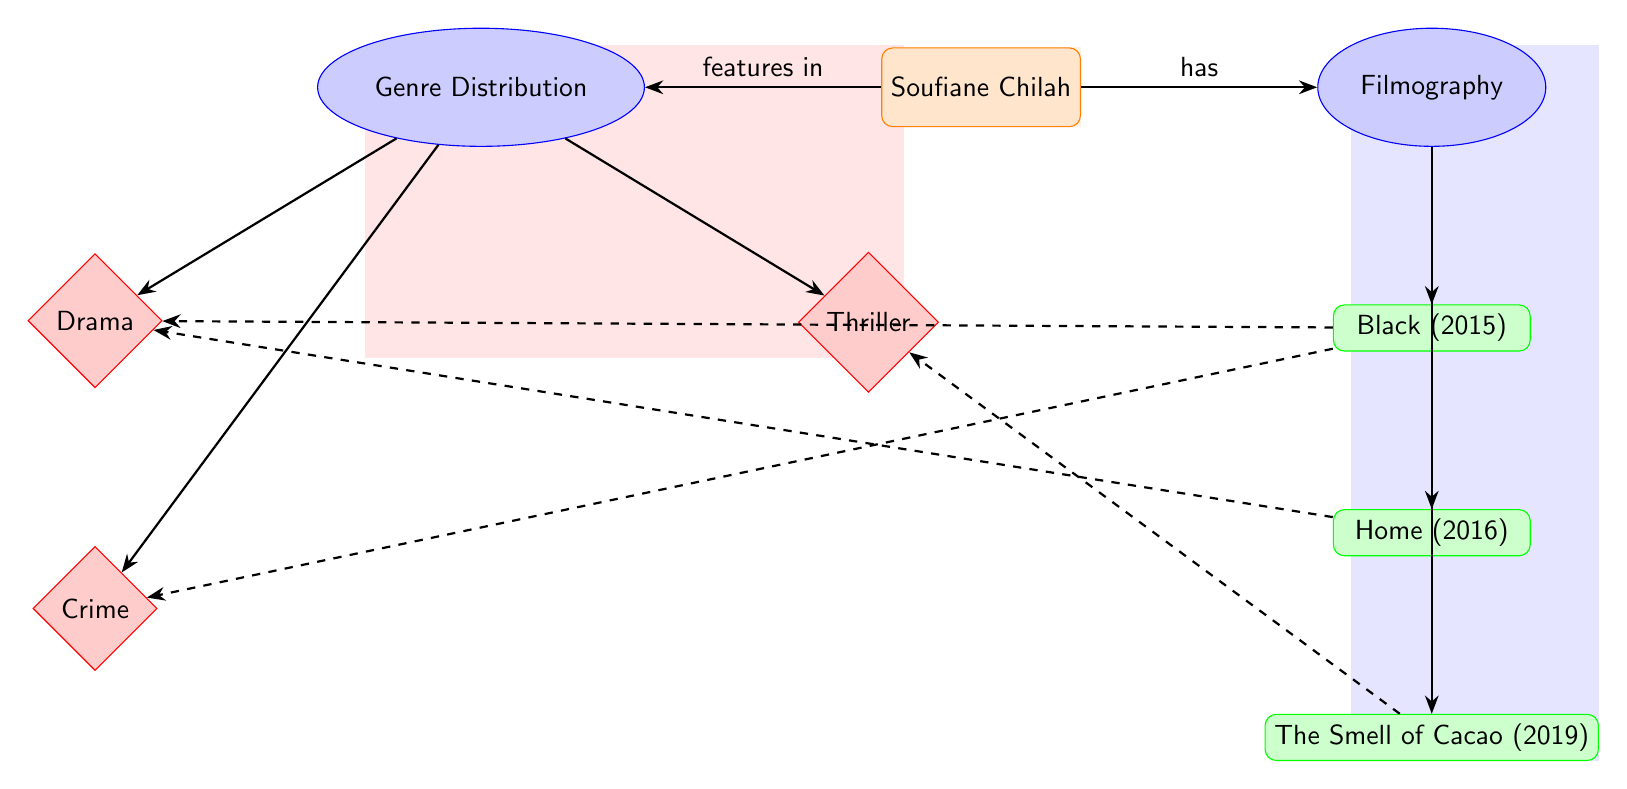What films are listed in Soufiane Chilah's filmography? The diagram shows three films listed under Soufiane Chilah's filmography: "Black (2015)", "Home (2016)", and "The Smell of Cacao (2019)". These are represented as nodes connected to the filmography node in the diagram.
Answer: Black (2015), Home (2016), The Smell of Cacao (2019) How many genres are featured in the diagram? There are three genres represented in the diagram: Drama, Crime, and Thriller. Each genre is depicted as a separate node connected to the genre distribution node. Counting these nodes gives a total of three genres.
Answer: 3 Which film corresponds to the Crime genre? Looking at the edges connecting the film nodes to the genre node, "Black (2015)" has dashed edges leading to both the Crime and Drama genres. This indicates that "Black" can be categorized under Crime.
Answer: Black (2015) Which film is classified as a Thriller? The film node "The Smell of Cacao (2019)" is connected by a dashed edge to the Thriller genre node, categorizing it under this genre. Thus, "The Smell of Cacao" is classified as a Thriller.
Answer: The Smell of Cacao (2019) What type of relationship connects Soufiane Chilah to the filmography node? The relationship is indicated by an edge labeled "has" connecting Soufiane Chilah to the filmography category node. This clearly indicates that Soufiane Chilah has a filmography that is represented in the diagram.
Answer: has Which genres does "Home (2016)" belong to? The dashed lines from the film node "Home (2016)" indicate that it is connected only to the Drama genre. Therefore, it belongs exclusively to the Drama genre.
Answer: Drama What color represents the genre nodes in the diagram? The genre nodes are represented by a diamond shape filled with red!20 color as indicated in the style settings of the diagram. This coloring visually distinguishes the genre category from others in the diagram.
Answer: Red How many films did Soufiane Chilah star in that belong to the Drama genre? Looking at the connections, both "Black (2015)" and "Home (2016)" have edges leading to the Drama genre. Therefore, two films are associated with the Drama genre.
Answer: 2 What is the relationship between the filmography and genre distribution nodes? The relationship is expressed through the edges connecting both categories to Soufiane Chilah. The filmography node is connected by the "has" edge, while genre distribution is associated with the "features in" edge, indicating the films belong to specific genres.
Answer: has / features in 